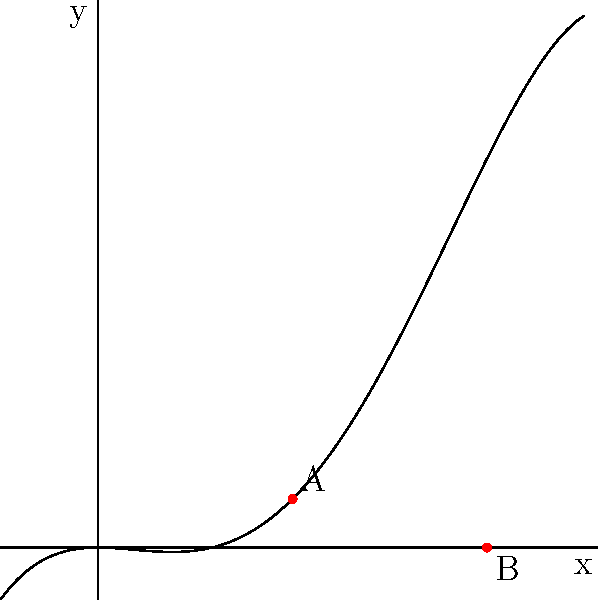As a computer network specialist, you're optimizing data transfer rates across a network. The performance of the network can be modeled by the function $f(x) = -\frac{1}{4}x^4 + x^3 - \frac{1}{2}x^2$, where $x$ represents the network load and $f(x)$ represents the data transfer rate. Find the maximum data transfer rate and the corresponding network load. To find the maximum data transfer rate, we need to find the highest point on the graph. This occurs at a local maximum, where the derivative of the function is zero and the second derivative is negative.

Step 1: Find the derivative of $f(x)$
$f'(x) = -x^3 + 3x^2 - x$

Step 2: Set $f'(x) = 0$ and solve for $x$
$-x^3 + 3x^2 - x = 0$
$x(-x^2 + 3x - 1) = 0$
$x(x - 1)(x - 2) = 0$
$x = 0, 1,$ or $2$

Step 3: Check the second derivative at these points
$f''(x) = -3x^2 + 6x - 1$
At $x = 1$: $f''(1) = -3 + 6 - 1 = 2 > 0$ (local minimum)
At $x = 2$: $f''(2) = -12 + 12 - 1 = -1 < 0$ (local maximum)

Step 4: Calculate the maximum value
The maximum occurs at $x = 1$
$f(1) = -\frac{1}{4}(1)^4 + (1)^3 - \frac{1}{2}(1)^2 = -0.25 + 1 - 0.5 = 0.25$

Therefore, the maximum data transfer rate is 0.25 units, occurring at a network load of 1 unit.
Answer: Maximum data transfer rate: 0.25 units; Corresponding network load: 1 unit 